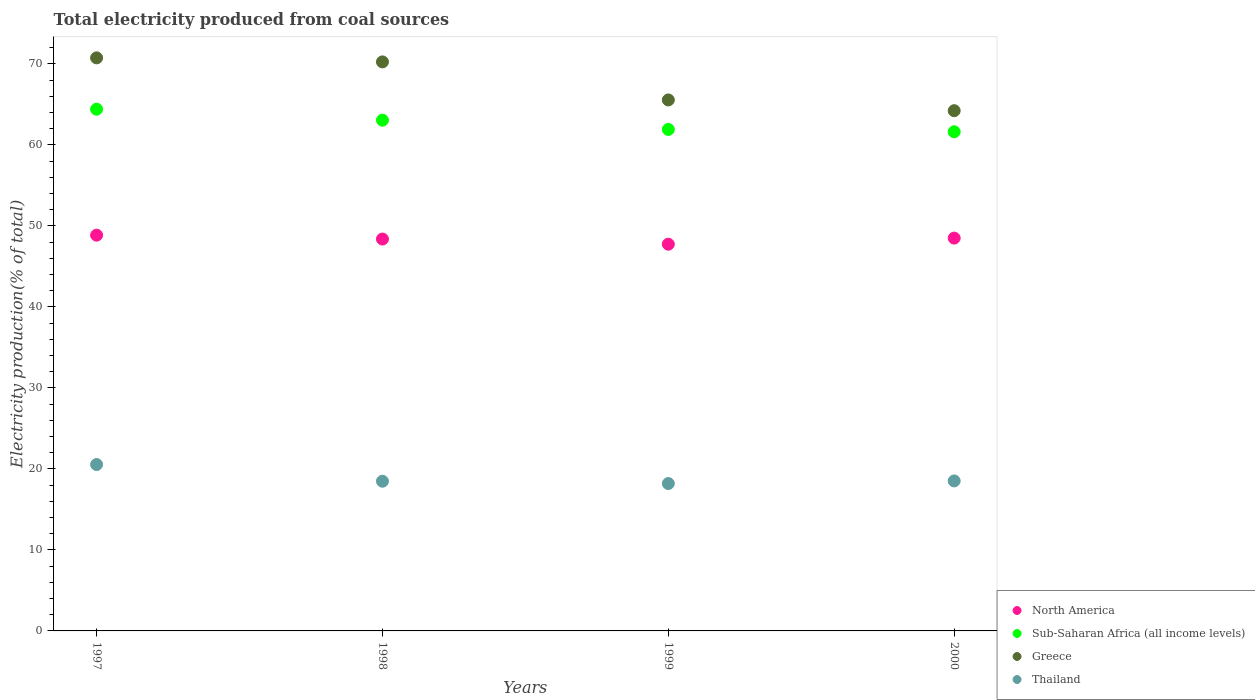How many different coloured dotlines are there?
Keep it short and to the point. 4. Is the number of dotlines equal to the number of legend labels?
Your answer should be very brief. Yes. What is the total electricity produced in North America in 1999?
Your answer should be compact. 47.74. Across all years, what is the maximum total electricity produced in Thailand?
Give a very brief answer. 20.54. Across all years, what is the minimum total electricity produced in Greece?
Make the answer very short. 64.23. What is the total total electricity produced in North America in the graph?
Offer a very short reply. 193.48. What is the difference between the total electricity produced in Greece in 1998 and that in 1999?
Ensure brevity in your answer.  4.7. What is the difference between the total electricity produced in North America in 1998 and the total electricity produced in Thailand in 1997?
Your response must be concise. 27.84. What is the average total electricity produced in Greece per year?
Offer a very short reply. 67.7. In the year 2000, what is the difference between the total electricity produced in Greece and total electricity produced in North America?
Make the answer very short. 15.73. In how many years, is the total electricity produced in North America greater than 4 %?
Offer a very short reply. 4. What is the ratio of the total electricity produced in Sub-Saharan Africa (all income levels) in 1998 to that in 1999?
Provide a short and direct response. 1.02. Is the total electricity produced in Sub-Saharan Africa (all income levels) in 1997 less than that in 1998?
Keep it short and to the point. No. Is the difference between the total electricity produced in Greece in 1998 and 1999 greater than the difference between the total electricity produced in North America in 1998 and 1999?
Provide a short and direct response. Yes. What is the difference between the highest and the second highest total electricity produced in Greece?
Give a very brief answer. 0.5. What is the difference between the highest and the lowest total electricity produced in North America?
Your response must be concise. 1.12. In how many years, is the total electricity produced in Sub-Saharan Africa (all income levels) greater than the average total electricity produced in Sub-Saharan Africa (all income levels) taken over all years?
Offer a very short reply. 2. Does the total electricity produced in Greece monotonically increase over the years?
Keep it short and to the point. No. Is the total electricity produced in Greece strictly greater than the total electricity produced in Thailand over the years?
Give a very brief answer. Yes. How many dotlines are there?
Make the answer very short. 4. How many years are there in the graph?
Make the answer very short. 4. What is the difference between two consecutive major ticks on the Y-axis?
Make the answer very short. 10. Are the values on the major ticks of Y-axis written in scientific E-notation?
Offer a very short reply. No. Does the graph contain any zero values?
Give a very brief answer. No. Does the graph contain grids?
Offer a very short reply. No. How are the legend labels stacked?
Keep it short and to the point. Vertical. What is the title of the graph?
Ensure brevity in your answer.  Total electricity produced from coal sources. What is the label or title of the X-axis?
Ensure brevity in your answer.  Years. What is the Electricity production(% of total) in North America in 1997?
Provide a short and direct response. 48.86. What is the Electricity production(% of total) of Sub-Saharan Africa (all income levels) in 1997?
Provide a succinct answer. 64.41. What is the Electricity production(% of total) in Greece in 1997?
Provide a short and direct response. 70.75. What is the Electricity production(% of total) in Thailand in 1997?
Your answer should be very brief. 20.54. What is the Electricity production(% of total) of North America in 1998?
Provide a short and direct response. 48.38. What is the Electricity production(% of total) in Sub-Saharan Africa (all income levels) in 1998?
Offer a terse response. 63.05. What is the Electricity production(% of total) of Greece in 1998?
Give a very brief answer. 70.25. What is the Electricity production(% of total) in Thailand in 1998?
Your answer should be compact. 18.48. What is the Electricity production(% of total) of North America in 1999?
Your answer should be compact. 47.74. What is the Electricity production(% of total) in Sub-Saharan Africa (all income levels) in 1999?
Offer a very short reply. 61.91. What is the Electricity production(% of total) of Greece in 1999?
Ensure brevity in your answer.  65.56. What is the Electricity production(% of total) in Thailand in 1999?
Keep it short and to the point. 18.2. What is the Electricity production(% of total) in North America in 2000?
Give a very brief answer. 48.5. What is the Electricity production(% of total) in Sub-Saharan Africa (all income levels) in 2000?
Ensure brevity in your answer.  61.62. What is the Electricity production(% of total) of Greece in 2000?
Provide a succinct answer. 64.23. What is the Electricity production(% of total) in Thailand in 2000?
Your answer should be compact. 18.52. Across all years, what is the maximum Electricity production(% of total) of North America?
Your answer should be very brief. 48.86. Across all years, what is the maximum Electricity production(% of total) in Sub-Saharan Africa (all income levels)?
Keep it short and to the point. 64.41. Across all years, what is the maximum Electricity production(% of total) of Greece?
Offer a very short reply. 70.75. Across all years, what is the maximum Electricity production(% of total) of Thailand?
Your answer should be very brief. 20.54. Across all years, what is the minimum Electricity production(% of total) in North America?
Your answer should be very brief. 47.74. Across all years, what is the minimum Electricity production(% of total) of Sub-Saharan Africa (all income levels)?
Your answer should be very brief. 61.62. Across all years, what is the minimum Electricity production(% of total) of Greece?
Make the answer very short. 64.23. Across all years, what is the minimum Electricity production(% of total) in Thailand?
Your answer should be very brief. 18.2. What is the total Electricity production(% of total) of North America in the graph?
Offer a very short reply. 193.48. What is the total Electricity production(% of total) of Sub-Saharan Africa (all income levels) in the graph?
Make the answer very short. 251. What is the total Electricity production(% of total) of Greece in the graph?
Your answer should be compact. 270.78. What is the total Electricity production(% of total) in Thailand in the graph?
Your response must be concise. 75.74. What is the difference between the Electricity production(% of total) in North America in 1997 and that in 1998?
Your answer should be very brief. 0.48. What is the difference between the Electricity production(% of total) in Sub-Saharan Africa (all income levels) in 1997 and that in 1998?
Give a very brief answer. 1.36. What is the difference between the Electricity production(% of total) of Greece in 1997 and that in 1998?
Your answer should be very brief. 0.5. What is the difference between the Electricity production(% of total) in Thailand in 1997 and that in 1998?
Provide a short and direct response. 2.06. What is the difference between the Electricity production(% of total) in North America in 1997 and that in 1999?
Ensure brevity in your answer.  1.12. What is the difference between the Electricity production(% of total) of Sub-Saharan Africa (all income levels) in 1997 and that in 1999?
Provide a succinct answer. 2.5. What is the difference between the Electricity production(% of total) in Greece in 1997 and that in 1999?
Offer a terse response. 5.19. What is the difference between the Electricity production(% of total) of Thailand in 1997 and that in 1999?
Ensure brevity in your answer.  2.35. What is the difference between the Electricity production(% of total) of North America in 1997 and that in 2000?
Make the answer very short. 0.36. What is the difference between the Electricity production(% of total) of Sub-Saharan Africa (all income levels) in 1997 and that in 2000?
Your answer should be compact. 2.79. What is the difference between the Electricity production(% of total) in Greece in 1997 and that in 2000?
Your answer should be compact. 6.52. What is the difference between the Electricity production(% of total) of Thailand in 1997 and that in 2000?
Keep it short and to the point. 2.03. What is the difference between the Electricity production(% of total) of North America in 1998 and that in 1999?
Offer a very short reply. 0.64. What is the difference between the Electricity production(% of total) in Sub-Saharan Africa (all income levels) in 1998 and that in 1999?
Provide a short and direct response. 1.14. What is the difference between the Electricity production(% of total) of Greece in 1998 and that in 1999?
Give a very brief answer. 4.7. What is the difference between the Electricity production(% of total) of Thailand in 1998 and that in 1999?
Provide a succinct answer. 0.29. What is the difference between the Electricity production(% of total) in North America in 1998 and that in 2000?
Offer a very short reply. -0.12. What is the difference between the Electricity production(% of total) of Sub-Saharan Africa (all income levels) in 1998 and that in 2000?
Your answer should be compact. 1.43. What is the difference between the Electricity production(% of total) of Greece in 1998 and that in 2000?
Ensure brevity in your answer.  6.02. What is the difference between the Electricity production(% of total) of Thailand in 1998 and that in 2000?
Your answer should be very brief. -0.04. What is the difference between the Electricity production(% of total) in North America in 1999 and that in 2000?
Offer a terse response. -0.75. What is the difference between the Electricity production(% of total) of Sub-Saharan Africa (all income levels) in 1999 and that in 2000?
Make the answer very short. 0.29. What is the difference between the Electricity production(% of total) in Greece in 1999 and that in 2000?
Give a very brief answer. 1.33. What is the difference between the Electricity production(% of total) in Thailand in 1999 and that in 2000?
Provide a succinct answer. -0.32. What is the difference between the Electricity production(% of total) of North America in 1997 and the Electricity production(% of total) of Sub-Saharan Africa (all income levels) in 1998?
Offer a very short reply. -14.19. What is the difference between the Electricity production(% of total) in North America in 1997 and the Electricity production(% of total) in Greece in 1998?
Provide a short and direct response. -21.39. What is the difference between the Electricity production(% of total) in North America in 1997 and the Electricity production(% of total) in Thailand in 1998?
Ensure brevity in your answer.  30.38. What is the difference between the Electricity production(% of total) in Sub-Saharan Africa (all income levels) in 1997 and the Electricity production(% of total) in Greece in 1998?
Offer a terse response. -5.84. What is the difference between the Electricity production(% of total) of Sub-Saharan Africa (all income levels) in 1997 and the Electricity production(% of total) of Thailand in 1998?
Make the answer very short. 45.93. What is the difference between the Electricity production(% of total) of Greece in 1997 and the Electricity production(% of total) of Thailand in 1998?
Keep it short and to the point. 52.27. What is the difference between the Electricity production(% of total) of North America in 1997 and the Electricity production(% of total) of Sub-Saharan Africa (all income levels) in 1999?
Ensure brevity in your answer.  -13.05. What is the difference between the Electricity production(% of total) of North America in 1997 and the Electricity production(% of total) of Greece in 1999?
Your response must be concise. -16.69. What is the difference between the Electricity production(% of total) in North America in 1997 and the Electricity production(% of total) in Thailand in 1999?
Ensure brevity in your answer.  30.66. What is the difference between the Electricity production(% of total) in Sub-Saharan Africa (all income levels) in 1997 and the Electricity production(% of total) in Greece in 1999?
Offer a terse response. -1.15. What is the difference between the Electricity production(% of total) in Sub-Saharan Africa (all income levels) in 1997 and the Electricity production(% of total) in Thailand in 1999?
Your response must be concise. 46.21. What is the difference between the Electricity production(% of total) of Greece in 1997 and the Electricity production(% of total) of Thailand in 1999?
Provide a short and direct response. 52.55. What is the difference between the Electricity production(% of total) in North America in 1997 and the Electricity production(% of total) in Sub-Saharan Africa (all income levels) in 2000?
Offer a terse response. -12.76. What is the difference between the Electricity production(% of total) in North America in 1997 and the Electricity production(% of total) in Greece in 2000?
Keep it short and to the point. -15.37. What is the difference between the Electricity production(% of total) of North America in 1997 and the Electricity production(% of total) of Thailand in 2000?
Offer a terse response. 30.34. What is the difference between the Electricity production(% of total) of Sub-Saharan Africa (all income levels) in 1997 and the Electricity production(% of total) of Greece in 2000?
Offer a terse response. 0.18. What is the difference between the Electricity production(% of total) of Sub-Saharan Africa (all income levels) in 1997 and the Electricity production(% of total) of Thailand in 2000?
Your answer should be compact. 45.89. What is the difference between the Electricity production(% of total) in Greece in 1997 and the Electricity production(% of total) in Thailand in 2000?
Give a very brief answer. 52.23. What is the difference between the Electricity production(% of total) of North America in 1998 and the Electricity production(% of total) of Sub-Saharan Africa (all income levels) in 1999?
Give a very brief answer. -13.53. What is the difference between the Electricity production(% of total) in North America in 1998 and the Electricity production(% of total) in Greece in 1999?
Offer a very short reply. -17.18. What is the difference between the Electricity production(% of total) of North America in 1998 and the Electricity production(% of total) of Thailand in 1999?
Offer a terse response. 30.18. What is the difference between the Electricity production(% of total) of Sub-Saharan Africa (all income levels) in 1998 and the Electricity production(% of total) of Greece in 1999?
Provide a succinct answer. -2.5. What is the difference between the Electricity production(% of total) in Sub-Saharan Africa (all income levels) in 1998 and the Electricity production(% of total) in Thailand in 1999?
Your answer should be very brief. 44.86. What is the difference between the Electricity production(% of total) of Greece in 1998 and the Electricity production(% of total) of Thailand in 1999?
Provide a short and direct response. 52.05. What is the difference between the Electricity production(% of total) in North America in 1998 and the Electricity production(% of total) in Sub-Saharan Africa (all income levels) in 2000?
Your answer should be very brief. -13.24. What is the difference between the Electricity production(% of total) in North America in 1998 and the Electricity production(% of total) in Greece in 2000?
Your response must be concise. -15.85. What is the difference between the Electricity production(% of total) of North America in 1998 and the Electricity production(% of total) of Thailand in 2000?
Make the answer very short. 29.86. What is the difference between the Electricity production(% of total) in Sub-Saharan Africa (all income levels) in 1998 and the Electricity production(% of total) in Greece in 2000?
Keep it short and to the point. -1.17. What is the difference between the Electricity production(% of total) of Sub-Saharan Africa (all income levels) in 1998 and the Electricity production(% of total) of Thailand in 2000?
Keep it short and to the point. 44.54. What is the difference between the Electricity production(% of total) of Greece in 1998 and the Electricity production(% of total) of Thailand in 2000?
Keep it short and to the point. 51.73. What is the difference between the Electricity production(% of total) in North America in 1999 and the Electricity production(% of total) in Sub-Saharan Africa (all income levels) in 2000?
Make the answer very short. -13.88. What is the difference between the Electricity production(% of total) in North America in 1999 and the Electricity production(% of total) in Greece in 2000?
Give a very brief answer. -16.48. What is the difference between the Electricity production(% of total) of North America in 1999 and the Electricity production(% of total) of Thailand in 2000?
Provide a succinct answer. 29.23. What is the difference between the Electricity production(% of total) in Sub-Saharan Africa (all income levels) in 1999 and the Electricity production(% of total) in Greece in 2000?
Provide a succinct answer. -2.31. What is the difference between the Electricity production(% of total) in Sub-Saharan Africa (all income levels) in 1999 and the Electricity production(% of total) in Thailand in 2000?
Make the answer very short. 43.4. What is the difference between the Electricity production(% of total) of Greece in 1999 and the Electricity production(% of total) of Thailand in 2000?
Ensure brevity in your answer.  47.04. What is the average Electricity production(% of total) in North America per year?
Offer a terse response. 48.37. What is the average Electricity production(% of total) in Sub-Saharan Africa (all income levels) per year?
Ensure brevity in your answer.  62.75. What is the average Electricity production(% of total) of Greece per year?
Your response must be concise. 67.7. What is the average Electricity production(% of total) in Thailand per year?
Ensure brevity in your answer.  18.94. In the year 1997, what is the difference between the Electricity production(% of total) of North America and Electricity production(% of total) of Sub-Saharan Africa (all income levels)?
Offer a very short reply. -15.55. In the year 1997, what is the difference between the Electricity production(% of total) in North America and Electricity production(% of total) in Greece?
Offer a terse response. -21.89. In the year 1997, what is the difference between the Electricity production(% of total) in North America and Electricity production(% of total) in Thailand?
Your answer should be compact. 28.32. In the year 1997, what is the difference between the Electricity production(% of total) of Sub-Saharan Africa (all income levels) and Electricity production(% of total) of Greece?
Ensure brevity in your answer.  -6.34. In the year 1997, what is the difference between the Electricity production(% of total) of Sub-Saharan Africa (all income levels) and Electricity production(% of total) of Thailand?
Make the answer very short. 43.87. In the year 1997, what is the difference between the Electricity production(% of total) of Greece and Electricity production(% of total) of Thailand?
Your answer should be compact. 50.21. In the year 1998, what is the difference between the Electricity production(% of total) of North America and Electricity production(% of total) of Sub-Saharan Africa (all income levels)?
Offer a very short reply. -14.67. In the year 1998, what is the difference between the Electricity production(% of total) of North America and Electricity production(% of total) of Greece?
Your response must be concise. -21.87. In the year 1998, what is the difference between the Electricity production(% of total) in North America and Electricity production(% of total) in Thailand?
Your answer should be compact. 29.9. In the year 1998, what is the difference between the Electricity production(% of total) of Sub-Saharan Africa (all income levels) and Electricity production(% of total) of Greece?
Offer a very short reply. -7.2. In the year 1998, what is the difference between the Electricity production(% of total) in Sub-Saharan Africa (all income levels) and Electricity production(% of total) in Thailand?
Provide a short and direct response. 44.57. In the year 1998, what is the difference between the Electricity production(% of total) of Greece and Electricity production(% of total) of Thailand?
Offer a very short reply. 51.77. In the year 1999, what is the difference between the Electricity production(% of total) in North America and Electricity production(% of total) in Sub-Saharan Africa (all income levels)?
Ensure brevity in your answer.  -14.17. In the year 1999, what is the difference between the Electricity production(% of total) in North America and Electricity production(% of total) in Greece?
Make the answer very short. -17.81. In the year 1999, what is the difference between the Electricity production(% of total) of North America and Electricity production(% of total) of Thailand?
Give a very brief answer. 29.55. In the year 1999, what is the difference between the Electricity production(% of total) of Sub-Saharan Africa (all income levels) and Electricity production(% of total) of Greece?
Your response must be concise. -3.64. In the year 1999, what is the difference between the Electricity production(% of total) in Sub-Saharan Africa (all income levels) and Electricity production(% of total) in Thailand?
Provide a succinct answer. 43.72. In the year 1999, what is the difference between the Electricity production(% of total) in Greece and Electricity production(% of total) in Thailand?
Offer a terse response. 47.36. In the year 2000, what is the difference between the Electricity production(% of total) of North America and Electricity production(% of total) of Sub-Saharan Africa (all income levels)?
Provide a succinct answer. -13.13. In the year 2000, what is the difference between the Electricity production(% of total) in North America and Electricity production(% of total) in Greece?
Your response must be concise. -15.73. In the year 2000, what is the difference between the Electricity production(% of total) of North America and Electricity production(% of total) of Thailand?
Keep it short and to the point. 29.98. In the year 2000, what is the difference between the Electricity production(% of total) of Sub-Saharan Africa (all income levels) and Electricity production(% of total) of Greece?
Keep it short and to the point. -2.6. In the year 2000, what is the difference between the Electricity production(% of total) of Sub-Saharan Africa (all income levels) and Electricity production(% of total) of Thailand?
Make the answer very short. 43.11. In the year 2000, what is the difference between the Electricity production(% of total) in Greece and Electricity production(% of total) in Thailand?
Your answer should be very brief. 45.71. What is the ratio of the Electricity production(% of total) in North America in 1997 to that in 1998?
Keep it short and to the point. 1.01. What is the ratio of the Electricity production(% of total) of Sub-Saharan Africa (all income levels) in 1997 to that in 1998?
Offer a very short reply. 1.02. What is the ratio of the Electricity production(% of total) in Greece in 1997 to that in 1998?
Give a very brief answer. 1.01. What is the ratio of the Electricity production(% of total) in Thailand in 1997 to that in 1998?
Give a very brief answer. 1.11. What is the ratio of the Electricity production(% of total) in North America in 1997 to that in 1999?
Provide a succinct answer. 1.02. What is the ratio of the Electricity production(% of total) in Sub-Saharan Africa (all income levels) in 1997 to that in 1999?
Offer a very short reply. 1.04. What is the ratio of the Electricity production(% of total) of Greece in 1997 to that in 1999?
Make the answer very short. 1.08. What is the ratio of the Electricity production(% of total) of Thailand in 1997 to that in 1999?
Your response must be concise. 1.13. What is the ratio of the Electricity production(% of total) in North America in 1997 to that in 2000?
Keep it short and to the point. 1.01. What is the ratio of the Electricity production(% of total) of Sub-Saharan Africa (all income levels) in 1997 to that in 2000?
Give a very brief answer. 1.05. What is the ratio of the Electricity production(% of total) of Greece in 1997 to that in 2000?
Provide a succinct answer. 1.1. What is the ratio of the Electricity production(% of total) in Thailand in 1997 to that in 2000?
Provide a short and direct response. 1.11. What is the ratio of the Electricity production(% of total) of North America in 1998 to that in 1999?
Keep it short and to the point. 1.01. What is the ratio of the Electricity production(% of total) in Sub-Saharan Africa (all income levels) in 1998 to that in 1999?
Provide a short and direct response. 1.02. What is the ratio of the Electricity production(% of total) in Greece in 1998 to that in 1999?
Make the answer very short. 1.07. What is the ratio of the Electricity production(% of total) of Thailand in 1998 to that in 1999?
Provide a short and direct response. 1.02. What is the ratio of the Electricity production(% of total) of Sub-Saharan Africa (all income levels) in 1998 to that in 2000?
Your response must be concise. 1.02. What is the ratio of the Electricity production(% of total) in Greece in 1998 to that in 2000?
Give a very brief answer. 1.09. What is the ratio of the Electricity production(% of total) of North America in 1999 to that in 2000?
Keep it short and to the point. 0.98. What is the ratio of the Electricity production(% of total) in Sub-Saharan Africa (all income levels) in 1999 to that in 2000?
Make the answer very short. 1. What is the ratio of the Electricity production(% of total) in Greece in 1999 to that in 2000?
Make the answer very short. 1.02. What is the ratio of the Electricity production(% of total) of Thailand in 1999 to that in 2000?
Provide a succinct answer. 0.98. What is the difference between the highest and the second highest Electricity production(% of total) in North America?
Give a very brief answer. 0.36. What is the difference between the highest and the second highest Electricity production(% of total) of Sub-Saharan Africa (all income levels)?
Keep it short and to the point. 1.36. What is the difference between the highest and the second highest Electricity production(% of total) of Greece?
Ensure brevity in your answer.  0.5. What is the difference between the highest and the second highest Electricity production(% of total) in Thailand?
Make the answer very short. 2.03. What is the difference between the highest and the lowest Electricity production(% of total) in North America?
Your answer should be compact. 1.12. What is the difference between the highest and the lowest Electricity production(% of total) of Sub-Saharan Africa (all income levels)?
Your response must be concise. 2.79. What is the difference between the highest and the lowest Electricity production(% of total) of Greece?
Provide a short and direct response. 6.52. What is the difference between the highest and the lowest Electricity production(% of total) of Thailand?
Make the answer very short. 2.35. 